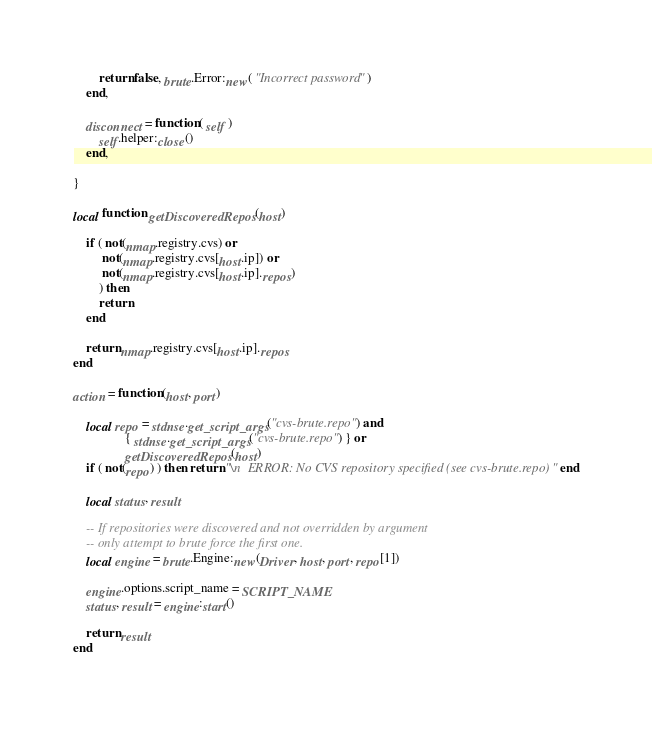<code> <loc_0><loc_0><loc_500><loc_500><_Lua_>		return false, brute.Error:new( "Incorrect password" )
	end,
	
	disconnect = function( self )
		self.helper:close()
	end,
		
}

local function getDiscoveredRepos(host)

	if ( not(nmap.registry.cvs) or 
		 not(nmap.registry.cvs[host.ip]) or
		 not(nmap.registry.cvs[host.ip].repos)
		) then 
		return
	end
		
	return nmap.registry.cvs[host.ip].repos
end

action = function(host, port)
	
	local repo = stdnse.get_script_args("cvs-brute.repo") and 
				{ stdnse.get_script_args("cvs-brute.repo") } or 
				getDiscoveredRepos(host)
	if ( not(repo) ) then return "\n  ERROR: No CVS repository specified (see cvs-brute.repo)" end

	local status, result
	
	-- If repositories were discovered and not overridden by argument
	-- only attempt to brute force the first one.
	local engine = brute.Engine:new(Driver, host, port, repo[1])
	
	engine.options.script_name = SCRIPT_NAME	
	status, result = engine:start()

	return result
end

</code> 